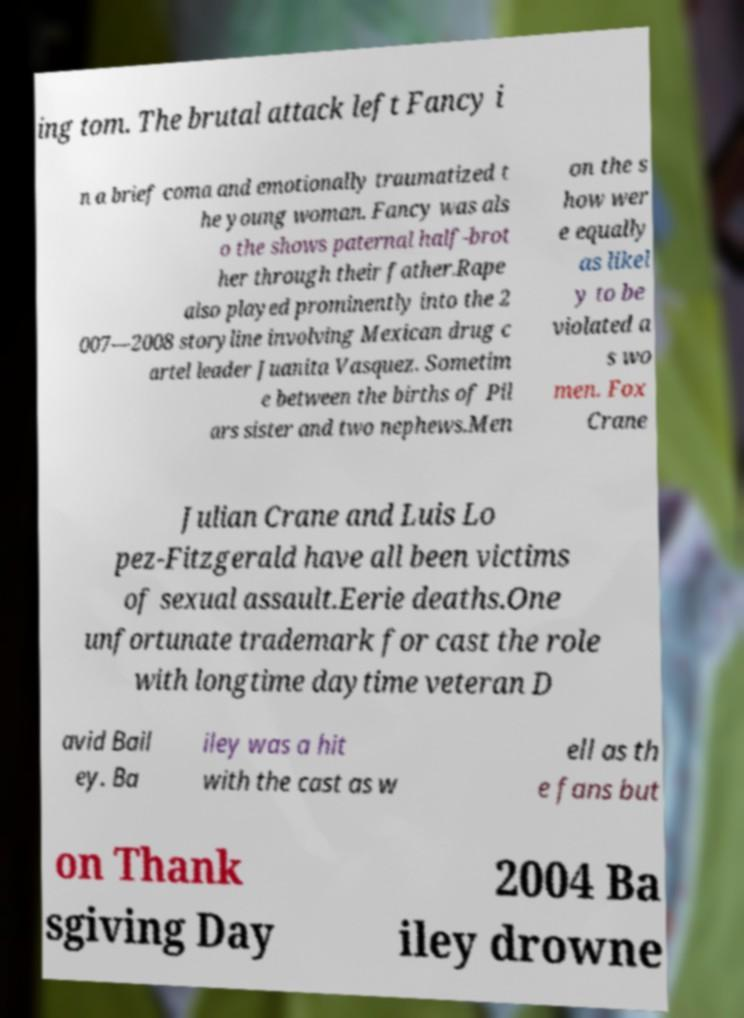There's text embedded in this image that I need extracted. Can you transcribe it verbatim? ing tom. The brutal attack left Fancy i n a brief coma and emotionally traumatized t he young woman. Fancy was als o the shows paternal half-brot her through their father.Rape also played prominently into the 2 007—2008 storyline involving Mexican drug c artel leader Juanita Vasquez. Sometim e between the births of Pil ars sister and two nephews.Men on the s how wer e equally as likel y to be violated a s wo men. Fox Crane Julian Crane and Luis Lo pez-Fitzgerald have all been victims of sexual assault.Eerie deaths.One unfortunate trademark for cast the role with longtime daytime veteran D avid Bail ey. Ba iley was a hit with the cast as w ell as th e fans but on Thank sgiving Day 2004 Ba iley drowne 